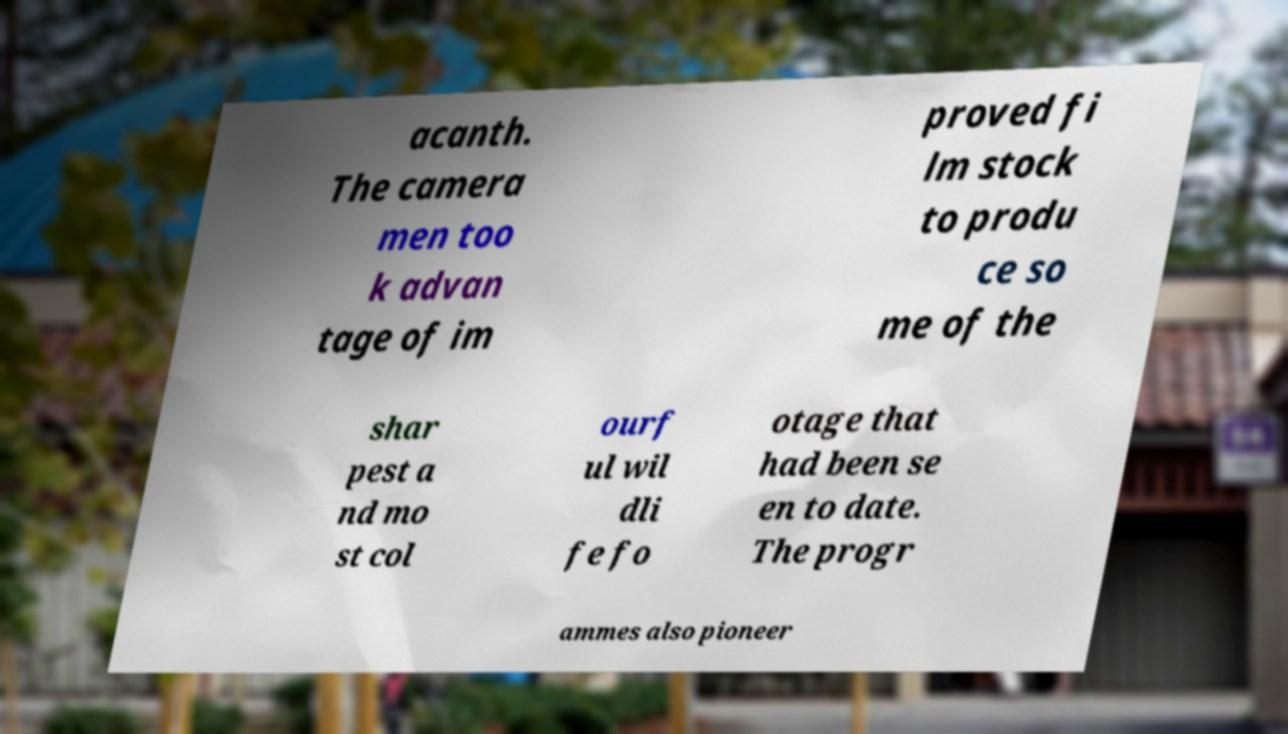I need the written content from this picture converted into text. Can you do that? acanth. The camera men too k advan tage of im proved fi lm stock to produ ce so me of the shar pest a nd mo st col ourf ul wil dli fe fo otage that had been se en to date. The progr ammes also pioneer 